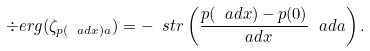<formula> <loc_0><loc_0><loc_500><loc_500>\div e r g ( \zeta _ { p ( \ a d x ) a } ) = - \ s t r \left ( \frac { p ( \ a d x ) - p ( 0 ) } { \ a d x } \ a d a \right ) .</formula> 